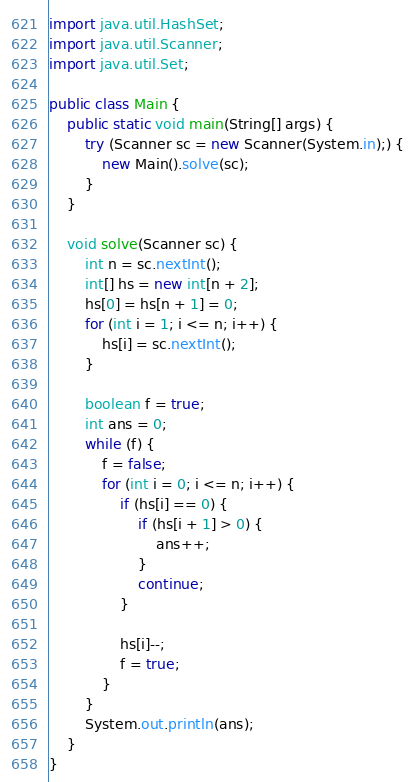<code> <loc_0><loc_0><loc_500><loc_500><_Java_>import java.util.HashSet;
import java.util.Scanner;
import java.util.Set;

public class Main {
    public static void main(String[] args) {
        try (Scanner sc = new Scanner(System.in);) {
            new Main().solve(sc);
        }
    }

    void solve(Scanner sc) {
        int n = sc.nextInt();
        int[] hs = new int[n + 2];
        hs[0] = hs[n + 1] = 0;
        for (int i = 1; i <= n; i++) {
            hs[i] = sc.nextInt();
        }

        boolean f = true;
        int ans = 0;
        while (f) {
            f = false;
            for (int i = 0; i <= n; i++) {
                if (hs[i] == 0) {
                    if (hs[i + 1] > 0) {
                        ans++;
                    }
                    continue;
                } 
                
                hs[i]--;
                f = true;
            }
        }
        System.out.println(ans);
    }
}
</code> 